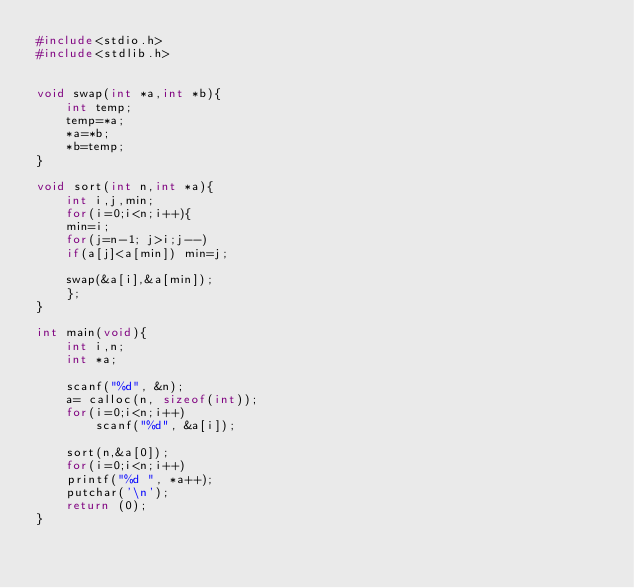<code> <loc_0><loc_0><loc_500><loc_500><_C_>#include<stdio.h>
#include<stdlib.h>


void swap(int *a,int *b){
	int temp;
	temp=*a;
	*a=*b;
	*b=temp;
}

void sort(int n,int *a){
	int i,j,min;
	for(i=0;i<n;i++){
	min=i;
	for(j=n-1; j>i;j--)
	if(a[j]<a[min]) min=j;
	
	swap(&a[i],&a[min]);
	};
}

int main(void){
	int i,n;
	int *a;

	scanf("%d", &n);
	a= calloc(n, sizeof(int));
	for(i=0;i<n;i++)
		scanf("%d", &a[i]);
	
	sort(n,&a[0]);
	for(i=0;i<n;i++)
	printf("%d ", *a++);
	putchar('\n');
	return (0);
}</code> 